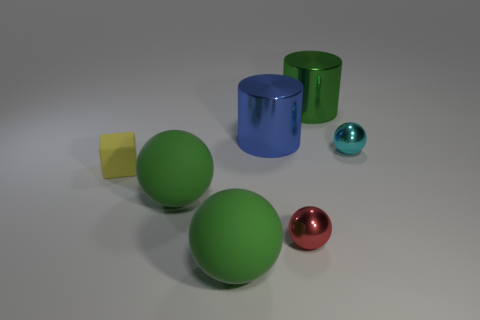Subtract all blue cubes. How many green balls are left? 2 Subtract all small red shiny spheres. How many spheres are left? 3 Subtract all cyan balls. How many balls are left? 3 Add 1 gray matte spheres. How many objects exist? 8 Subtract all cylinders. How many objects are left? 5 Subtract all cyan spheres. Subtract all yellow cubes. How many spheres are left? 3 Subtract 1 yellow cubes. How many objects are left? 6 Subtract all rubber cubes. Subtract all large blue shiny objects. How many objects are left? 5 Add 6 small metallic balls. How many small metallic balls are left? 8 Add 6 yellow cubes. How many yellow cubes exist? 7 